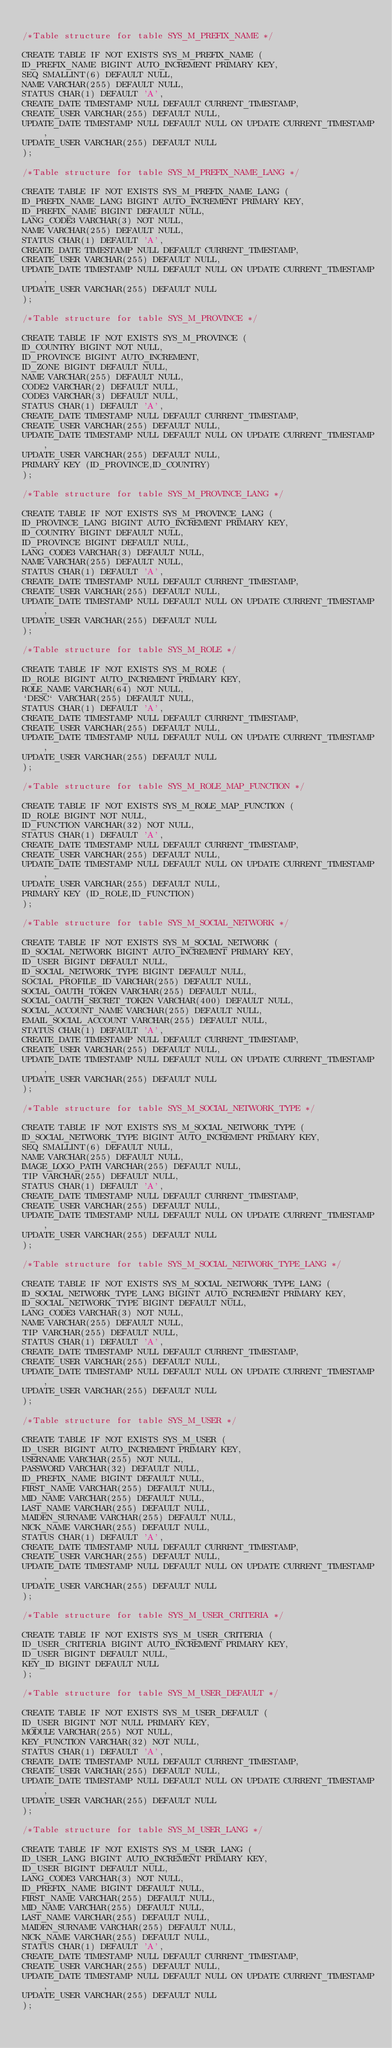<code> <loc_0><loc_0><loc_500><loc_500><_SQL_>
/*Table structure for table SYS_M_PREFIX_NAME */

CREATE TABLE IF NOT EXISTS SYS_M_PREFIX_NAME (
ID_PREFIX_NAME BIGINT AUTO_INCREMENT PRIMARY KEY,
SEQ SMALLINT(6) DEFAULT NULL,
NAME VARCHAR(255) DEFAULT NULL,
STATUS CHAR(1) DEFAULT 'A',
CREATE_DATE TIMESTAMP NULL DEFAULT CURRENT_TIMESTAMP,
CREATE_USER VARCHAR(255) DEFAULT NULL,
UPDATE_DATE TIMESTAMP NULL DEFAULT NULL ON UPDATE CURRENT_TIMESTAMP,
UPDATE_USER VARCHAR(255) DEFAULT NULL
);

/*Table structure for table SYS_M_PREFIX_NAME_LANG */

CREATE TABLE IF NOT EXISTS SYS_M_PREFIX_NAME_LANG (
ID_PREFIX_NAME_LANG BIGINT AUTO_INCREMENT PRIMARY KEY,
ID_PREFIX_NAME BIGINT DEFAULT NULL,
LANG_CODE3 VARCHAR(3) NOT NULL,
NAME VARCHAR(255) DEFAULT NULL,
STATUS CHAR(1) DEFAULT 'A',
CREATE_DATE TIMESTAMP NULL DEFAULT CURRENT_TIMESTAMP,
CREATE_USER VARCHAR(255) DEFAULT NULL,
UPDATE_DATE TIMESTAMP NULL DEFAULT NULL ON UPDATE CURRENT_TIMESTAMP,
UPDATE_USER VARCHAR(255) DEFAULT NULL
);

/*Table structure for table SYS_M_PROVINCE */

CREATE TABLE IF NOT EXISTS SYS_M_PROVINCE (
ID_COUNTRY BIGINT NOT NULL,
ID_PROVINCE BIGINT AUTO_INCREMENT,
ID_ZONE BIGINT DEFAULT NULL,
NAME VARCHAR(255) DEFAULT NULL,
CODE2 VARCHAR(2) DEFAULT NULL,
CODE3 VARCHAR(3) DEFAULT NULL,
STATUS CHAR(1) DEFAULT 'A',
CREATE_DATE TIMESTAMP NULL DEFAULT CURRENT_TIMESTAMP,
CREATE_USER VARCHAR(255) DEFAULT NULL,
UPDATE_DATE TIMESTAMP NULL DEFAULT NULL ON UPDATE CURRENT_TIMESTAMP,
UPDATE_USER VARCHAR(255) DEFAULT NULL,
PRIMARY KEY (ID_PROVINCE,ID_COUNTRY)
);

/*Table structure for table SYS_M_PROVINCE_LANG */

CREATE TABLE IF NOT EXISTS SYS_M_PROVINCE_LANG (
ID_PROVINCE_LANG BIGINT AUTO_INCREMENT PRIMARY KEY,
ID_COUNTRY BIGINT DEFAULT NULL,
ID_PROVINCE BIGINT DEFAULT NULL,
LANG_CODE3 VARCHAR(3) DEFAULT NULL,
NAME VARCHAR(255) DEFAULT NULL,
STATUS CHAR(1) DEFAULT 'A',
CREATE_DATE TIMESTAMP NULL DEFAULT CURRENT_TIMESTAMP,
CREATE_USER VARCHAR(255) DEFAULT NULL,
UPDATE_DATE TIMESTAMP NULL DEFAULT NULL ON UPDATE CURRENT_TIMESTAMP,
UPDATE_USER VARCHAR(255) DEFAULT NULL
);

/*Table structure for table SYS_M_ROLE */

CREATE TABLE IF NOT EXISTS SYS_M_ROLE (
ID_ROLE BIGINT AUTO_INCREMENT PRIMARY KEY,
ROLE_NAME VARCHAR(64) NOT NULL,
`DESC` VARCHAR(255) DEFAULT NULL,
STATUS CHAR(1) DEFAULT 'A',
CREATE_DATE TIMESTAMP NULL DEFAULT CURRENT_TIMESTAMP,
CREATE_USER VARCHAR(255) DEFAULT NULL,
UPDATE_DATE TIMESTAMP NULL DEFAULT NULL ON UPDATE CURRENT_TIMESTAMP,
UPDATE_USER VARCHAR(255) DEFAULT NULL
);

/*Table structure for table SYS_M_ROLE_MAP_FUNCTION */

CREATE TABLE IF NOT EXISTS SYS_M_ROLE_MAP_FUNCTION (
ID_ROLE BIGINT NOT NULL,
ID_FUNCTION VARCHAR(32) NOT NULL,
STATUS CHAR(1) DEFAULT 'A',
CREATE_DATE TIMESTAMP NULL DEFAULT CURRENT_TIMESTAMP,
CREATE_USER VARCHAR(255) DEFAULT NULL,
UPDATE_DATE TIMESTAMP NULL DEFAULT NULL ON UPDATE CURRENT_TIMESTAMP,
UPDATE_USER VARCHAR(255) DEFAULT NULL,
PRIMARY KEY (ID_ROLE,ID_FUNCTION)
);

/*Table structure for table SYS_M_SOCIAL_NETWORK */

CREATE TABLE IF NOT EXISTS SYS_M_SOCIAL_NETWORK (
ID_SOCIAL_NETWORK BIGINT AUTO_INCREMENT PRIMARY KEY,
ID_USER BIGINT DEFAULT NULL,
ID_SOCIAL_NETWORK_TYPE BIGINT DEFAULT NULL,
SOCIAL_PROFILE_ID VARCHAR(255) DEFAULT NULL,
SOCIAL_OAUTH_TOKEN VARCHAR(255) DEFAULT NULL,
SOCIAL_OAUTH_SECRET_TOKEN VARCHAR(400) DEFAULT NULL,
SOCIAL_ACCOUNT_NAME VARCHAR(255) DEFAULT NULL,
EMAIL_SOCIAL_ACCOUNT VARCHAR(255) DEFAULT NULL,
STATUS CHAR(1) DEFAULT 'A',
CREATE_DATE TIMESTAMP NULL DEFAULT CURRENT_TIMESTAMP,
CREATE_USER VARCHAR(255) DEFAULT NULL,
UPDATE_DATE TIMESTAMP NULL DEFAULT NULL ON UPDATE CURRENT_TIMESTAMP,
UPDATE_USER VARCHAR(255) DEFAULT NULL
);

/*Table structure for table SYS_M_SOCIAL_NETWORK_TYPE */

CREATE TABLE IF NOT EXISTS SYS_M_SOCIAL_NETWORK_TYPE (
ID_SOCIAL_NETWORK_TYPE BIGINT AUTO_INCREMENT PRIMARY KEY,
SEQ SMALLINT(6) DEFAULT NULL,
NAME VARCHAR(255) DEFAULT NULL,
IMAGE_LOGO_PATH VARCHAR(255) DEFAULT NULL,
TIP VARCHAR(255) DEFAULT NULL,
STATUS CHAR(1) DEFAULT 'A',
CREATE_DATE TIMESTAMP NULL DEFAULT CURRENT_TIMESTAMP,
CREATE_USER VARCHAR(255) DEFAULT NULL,
UPDATE_DATE TIMESTAMP NULL DEFAULT NULL ON UPDATE CURRENT_TIMESTAMP,
UPDATE_USER VARCHAR(255) DEFAULT NULL
);

/*Table structure for table SYS_M_SOCIAL_NETWORK_TYPE_LANG */

CREATE TABLE IF NOT EXISTS SYS_M_SOCIAL_NETWORK_TYPE_LANG (
ID_SOCIAL_NETWORK_TYPE_LANG BIGINT AUTO_INCREMENT PRIMARY KEY,
ID_SOCIAL_NETWORK_TYPE BIGINT DEFAULT NULL,
LANG_CODE3 VARCHAR(3) NOT NULL,
NAME VARCHAR(255) DEFAULT NULL,
TIP VARCHAR(255) DEFAULT NULL,
STATUS CHAR(1) DEFAULT 'A',
CREATE_DATE TIMESTAMP NULL DEFAULT CURRENT_TIMESTAMP,
CREATE_USER VARCHAR(255) DEFAULT NULL,
UPDATE_DATE TIMESTAMP NULL DEFAULT NULL ON UPDATE CURRENT_TIMESTAMP,
UPDATE_USER VARCHAR(255) DEFAULT NULL
);

/*Table structure for table SYS_M_USER */

CREATE TABLE IF NOT EXISTS SYS_M_USER (
ID_USER BIGINT AUTO_INCREMENT PRIMARY KEY,
USERNAME VARCHAR(255) NOT NULL,
PASSWORD VARCHAR(32) DEFAULT NULL,
ID_PREFIX_NAME BIGINT DEFAULT NULL,
FIRST_NAME VARCHAR(255) DEFAULT NULL,
MID_NAME VARCHAR(255) DEFAULT NULL,
LAST_NAME VARCHAR(255) DEFAULT NULL,
MAIDEN_SURNAME VARCHAR(255) DEFAULT NULL,
NICK_NAME VARCHAR(255) DEFAULT NULL,
STATUS CHAR(1) DEFAULT 'A',
CREATE_DATE TIMESTAMP NULL DEFAULT CURRENT_TIMESTAMP,
CREATE_USER VARCHAR(255) DEFAULT NULL,
UPDATE_DATE TIMESTAMP NULL DEFAULT NULL ON UPDATE CURRENT_TIMESTAMP,
UPDATE_USER VARCHAR(255) DEFAULT NULL
);

/*Table structure for table SYS_M_USER_CRITERIA */

CREATE TABLE IF NOT EXISTS SYS_M_USER_CRITERIA (
ID_USER_CRITERIA BIGINT AUTO_INCREMENT PRIMARY KEY,
ID_USER BIGINT DEFAULT NULL,
KEY_ID BIGINT DEFAULT NULL
);

/*Table structure for table SYS_M_USER_DEFAULT */

CREATE TABLE IF NOT EXISTS SYS_M_USER_DEFAULT (
ID_USER BIGINT NOT NULL PRIMARY KEY,
MODULE VARCHAR(255) NOT NULL,
KEY_FUNCTION VARCHAR(32) NOT NULL,
STATUS CHAR(1) DEFAULT 'A',
CREATE_DATE TIMESTAMP NULL DEFAULT CURRENT_TIMESTAMP,
CREATE_USER VARCHAR(255) DEFAULT NULL,
UPDATE_DATE TIMESTAMP NULL DEFAULT NULL ON UPDATE CURRENT_TIMESTAMP,
UPDATE_USER VARCHAR(255) DEFAULT NULL
);

/*Table structure for table SYS_M_USER_LANG */

CREATE TABLE IF NOT EXISTS SYS_M_USER_LANG (
ID_USER_LANG BIGINT AUTO_INCREMENT PRIMARY KEY,
ID_USER BIGINT DEFAULT NULL,
LANG_CODE3 VARCHAR(3) NOT NULL,
ID_PREFIX_NAME BIGINT DEFAULT NULL,
FIRST_NAME VARCHAR(255) DEFAULT NULL,
MID_NAME VARCHAR(255) DEFAULT NULL,
LAST_NAME VARCHAR(255) DEFAULT NULL,
MAIDEN_SURNAME VARCHAR(255) DEFAULT NULL,
NICK_NAME VARCHAR(255) DEFAULT NULL,
STATUS CHAR(1) DEFAULT 'A',
CREATE_DATE TIMESTAMP NULL DEFAULT CURRENT_TIMESTAMP,
CREATE_USER VARCHAR(255) DEFAULT NULL,
UPDATE_DATE TIMESTAMP NULL DEFAULT NULL ON UPDATE CURRENT_TIMESTAMP,
UPDATE_USER VARCHAR(255) DEFAULT NULL
);
</code> 